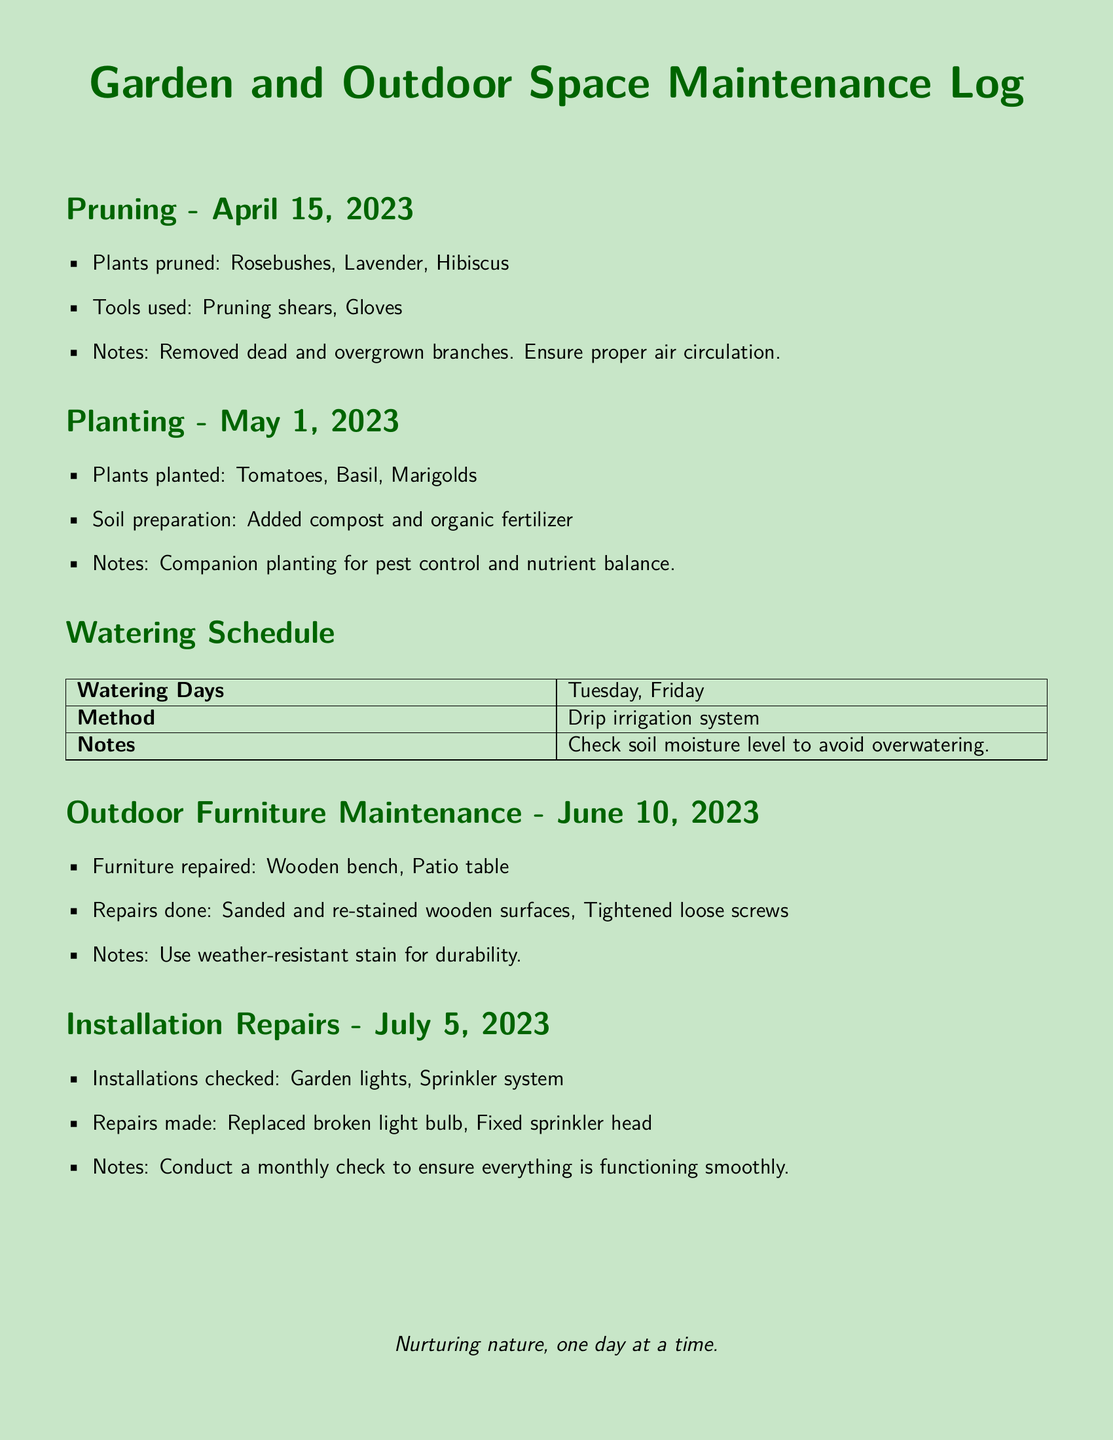What was pruned on April 15, 2023? The document lists the plants that were pruned on that date, specifically mentioning Rosebushes, Lavender, and Hibiscus.
Answer: Rosebushes, Lavender, Hibiscus What date did planting occur? The document indicates the date when planting took place, which is explicitly stated as May 1, 2023.
Answer: May 1, 2023 What method is used for watering? The document specifies that a drip irrigation system is the method employed for watering.
Answer: Drip irrigation system When was the outdoor furniture maintenance performed? The date for outdoor furniture maintenance is provided in the log as June 10, 2023.
Answer: June 10, 2023 What repairs were made to the outdoor furniture? The document contains a list of specific repairs made, including sanding and re-staining wooden surfaces as well as tightening loose screws.
Answer: Sanded and re-stained wooden surfaces, Tightened loose screws How often should the installations be checked? The document notes that a monthly check should be conducted to ensure installations are functioning smoothly.
Answer: Monthly Which plants were planted on May 1, 2023? The document details the plants that were planted, including Tomatoes, Basil, and Marigolds.
Answer: Tomatoes, Basil, Marigolds What is the purpose of adding compost and organic fertilizer? The document mentions that the purpose is linked to companion planting for pest control and nutrient balance.
Answer: Pest control and nutrient balance What was replaced during the installation repairs? The document indicates that a broken light bulb was replaced during the installation repairs.
Answer: Broken light bulb 